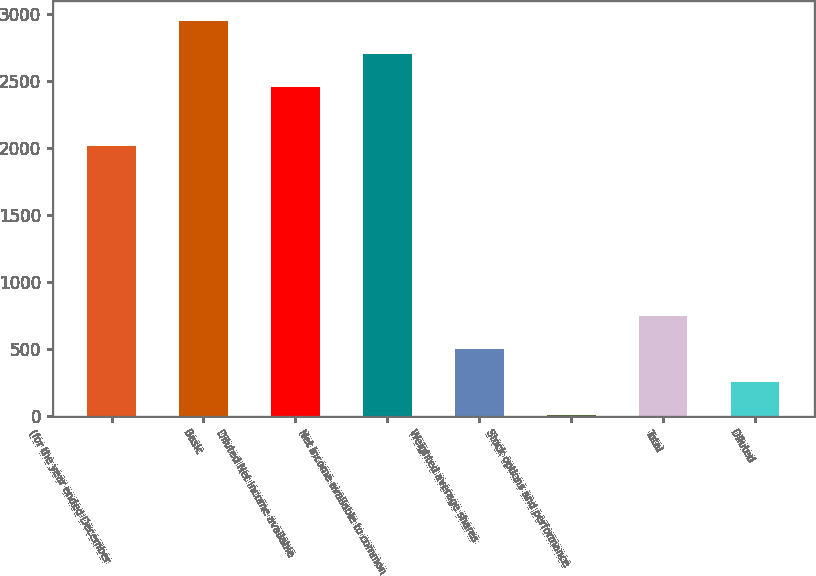Convert chart. <chart><loc_0><loc_0><loc_500><loc_500><bar_chart><fcel>(for the year ended December<fcel>Basic<fcel>Diluted Net income available<fcel>Net income available to common<fcel>Weighted average shares<fcel>Stock options and performance<fcel>Total<fcel>Diluted<nl><fcel>2012<fcel>2947.88<fcel>2454<fcel>2700.94<fcel>497.48<fcel>3.6<fcel>744.42<fcel>250.54<nl></chart> 